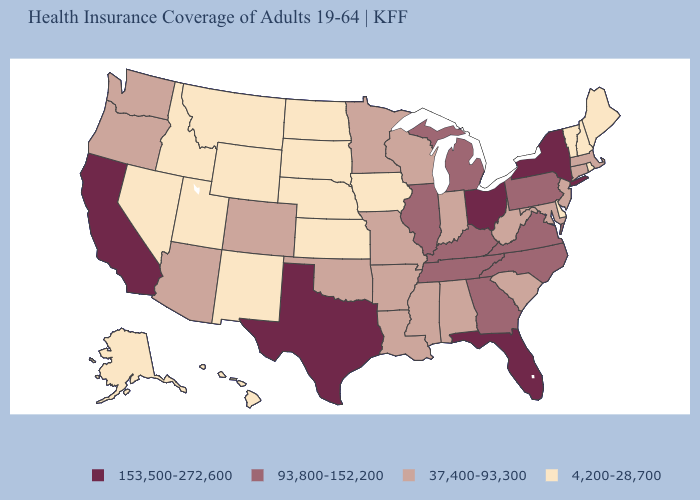Does the map have missing data?
Write a very short answer. No. Does New York have a higher value than Florida?
Short answer required. No. Does the map have missing data?
Quick response, please. No. What is the value of Arkansas?
Answer briefly. 37,400-93,300. What is the highest value in the USA?
Quick response, please. 153,500-272,600. Does Idaho have the same value as Texas?
Be succinct. No. What is the value of New Jersey?
Write a very short answer. 37,400-93,300. Is the legend a continuous bar?
Short answer required. No. What is the highest value in the MidWest ?
Keep it brief. 153,500-272,600. Does Florida have the same value as Ohio?
Concise answer only. Yes. Name the states that have a value in the range 153,500-272,600?
Be succinct. California, Florida, New York, Ohio, Texas. Is the legend a continuous bar?
Keep it brief. No. Does Washington have the same value as Alabama?
Write a very short answer. Yes. Does South Carolina have a lower value than Ohio?
Quick response, please. Yes. What is the value of Virginia?
Concise answer only. 93,800-152,200. 